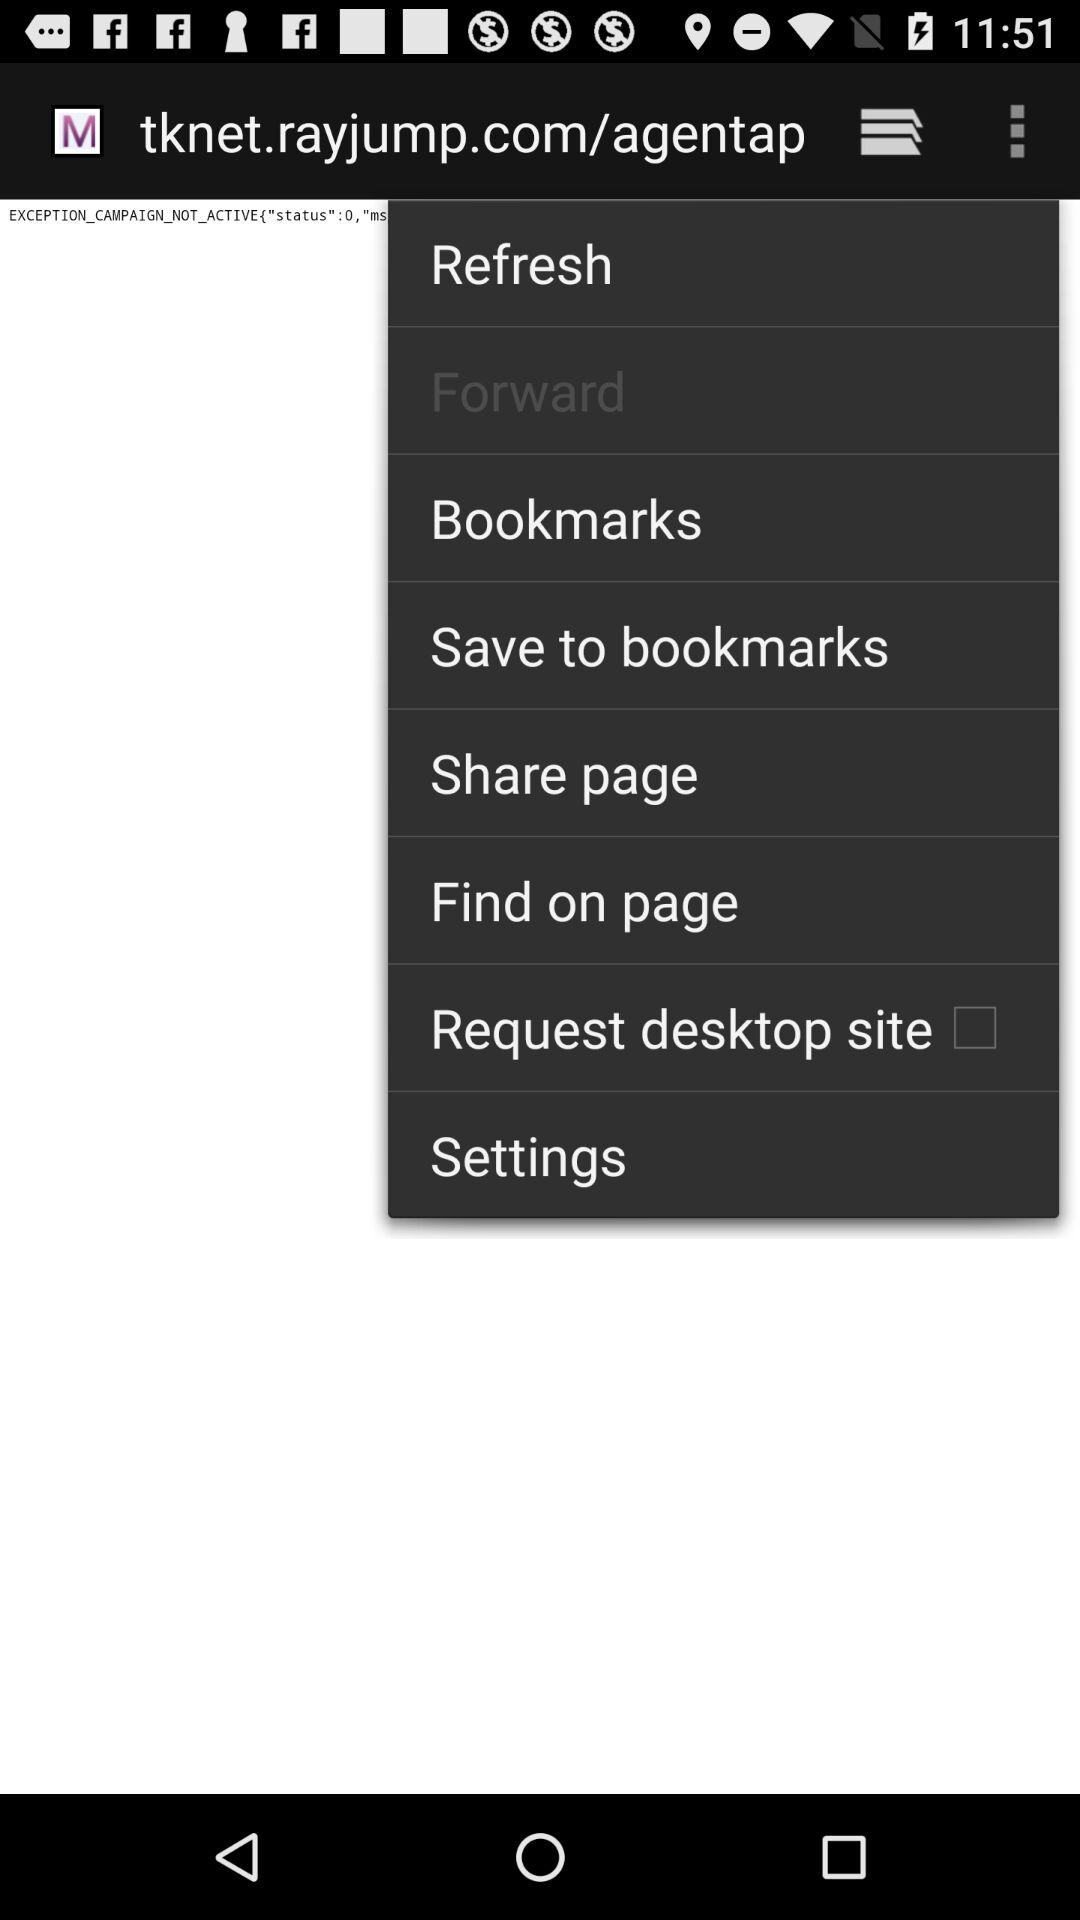What is the status of "Request desktop site"? The status is off. 